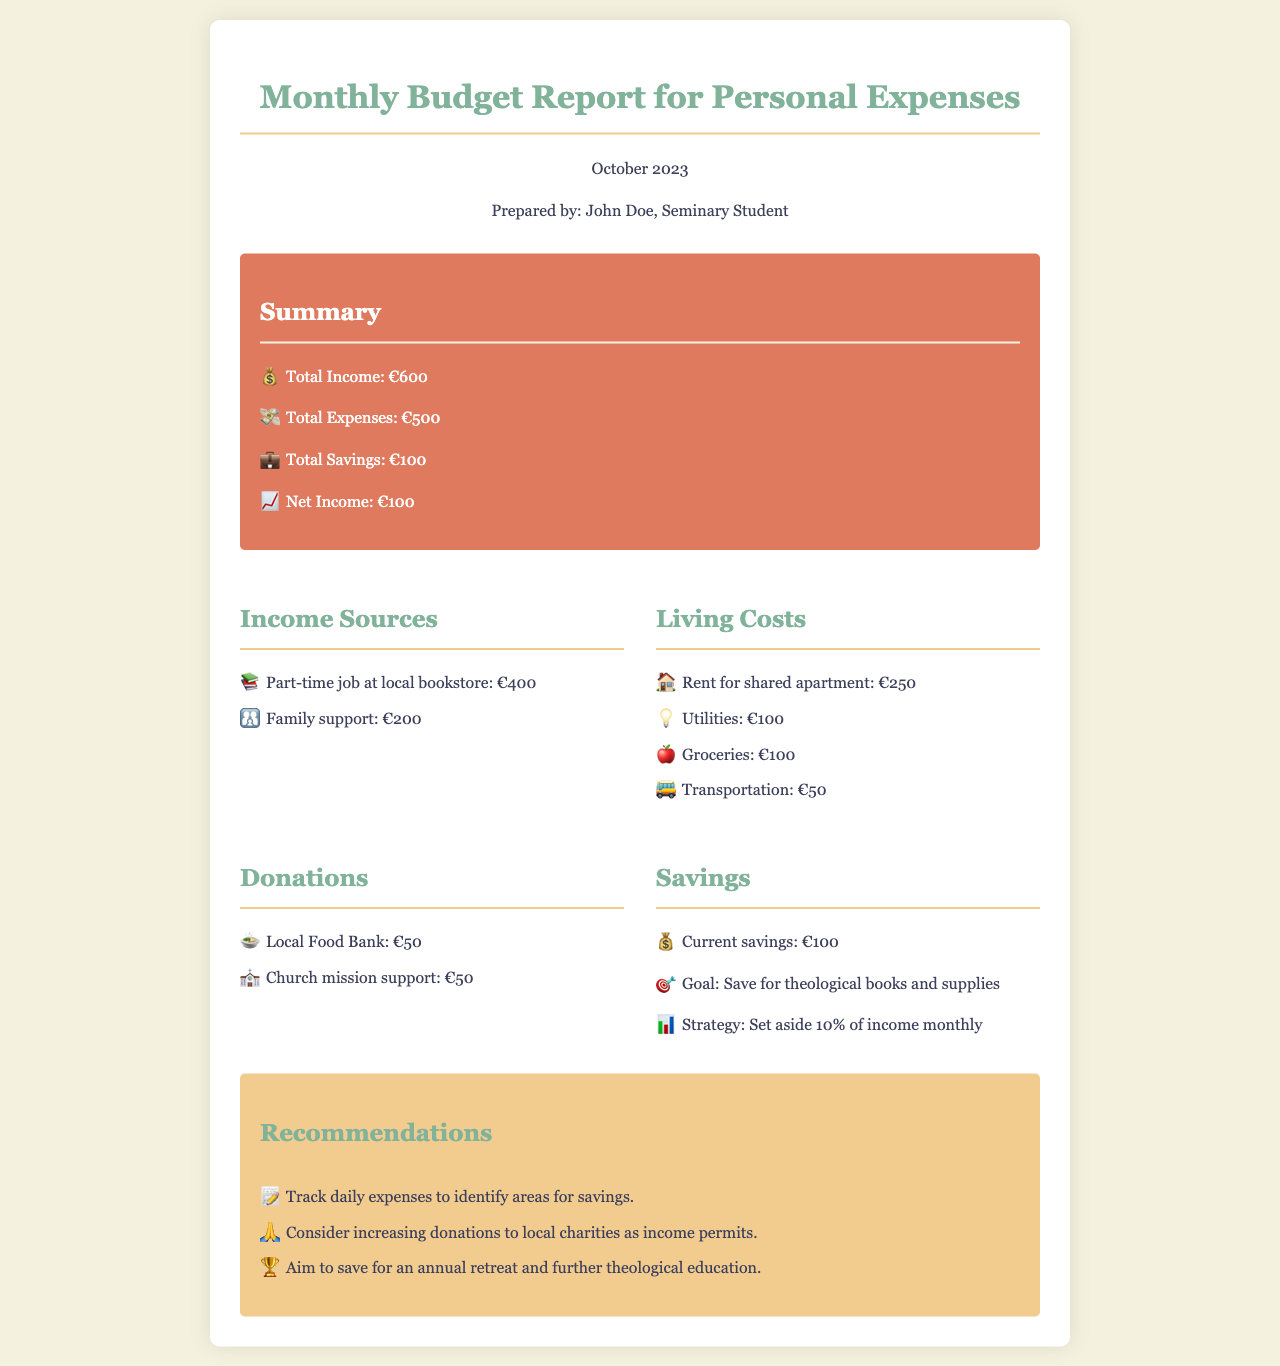What is the total income? The total income is presented in the summary section of the document. It is stated as €600.
Answer: €600 What are the living costs for groceries? The living costs for groceries are listed under Living Costs in the document, ensuring clarity on specific expenses. It is stated as €100.
Answer: €100 How much was donated to the local food bank? The donation amount to the local food bank is found in the Donations section of the document. It is stated as €50.
Answer: €50 What is the current savings amount? Current savings are highlighted in the savings section of the document; it states the savings amount directly.
Answer: €100 What is the overall net income? The net income is calculated by subtracting total expenses from total income, which is outlined in the summary. It is stated as €100.
Answer: €100 Why is it recommended to track daily expenses? The recommendation is based on the need to identify areas for savings, as suggested in the Recommendations section.
Answer: To identify areas for savings What is the goal for savings mentioned in the document? The goal for savings is explicitly outlined in the savings section, describing the purpose of saving.
Answer: Save for theological books and supplies How much is allocated for transportation in living costs? The amount allocated for transportation is specified in the Living Costs section, providing a clear understanding of this expense.
Answer: €50 